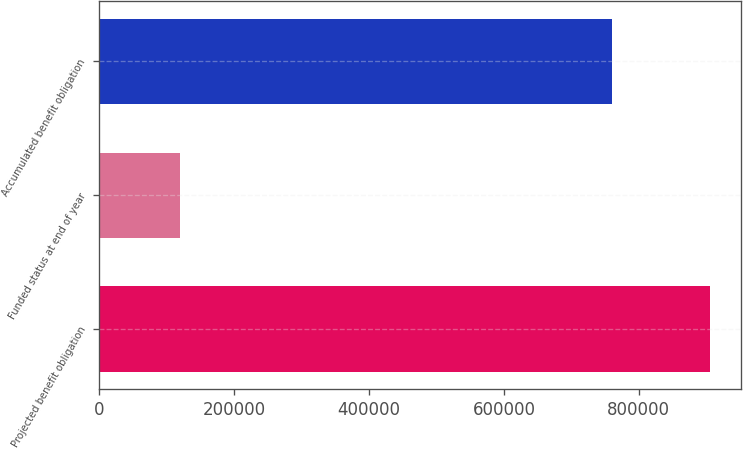Convert chart. <chart><loc_0><loc_0><loc_500><loc_500><bar_chart><fcel>Projected benefit obligation<fcel>Funded status at end of year<fcel>Accumulated benefit obligation<nl><fcel>905943<fcel>119193<fcel>760717<nl></chart> 